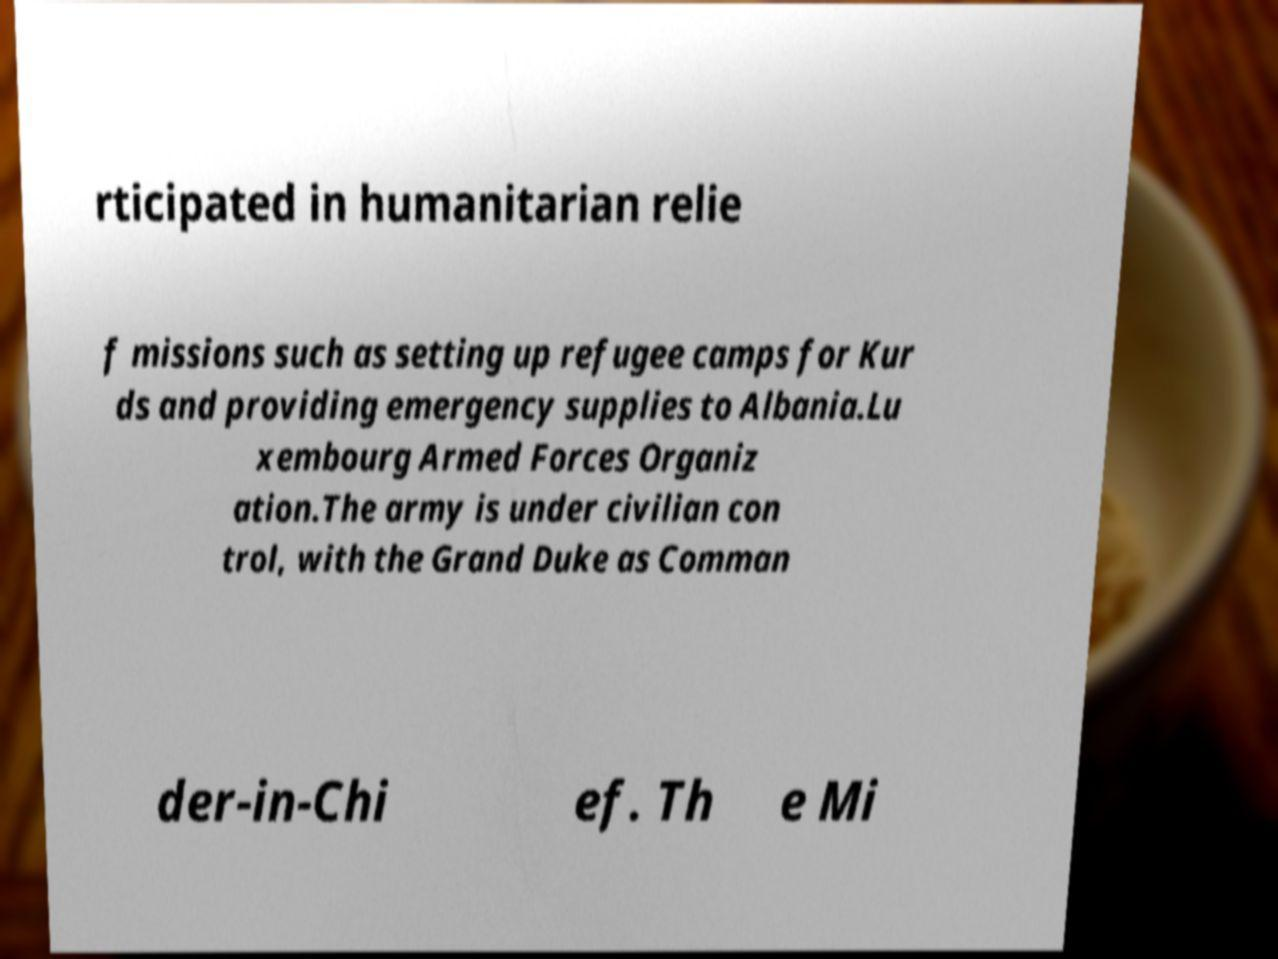What messages or text are displayed in this image? I need them in a readable, typed format. rticipated in humanitarian relie f missions such as setting up refugee camps for Kur ds and providing emergency supplies to Albania.Lu xembourg Armed Forces Organiz ation.The army is under civilian con trol, with the Grand Duke as Comman der-in-Chi ef. Th e Mi 